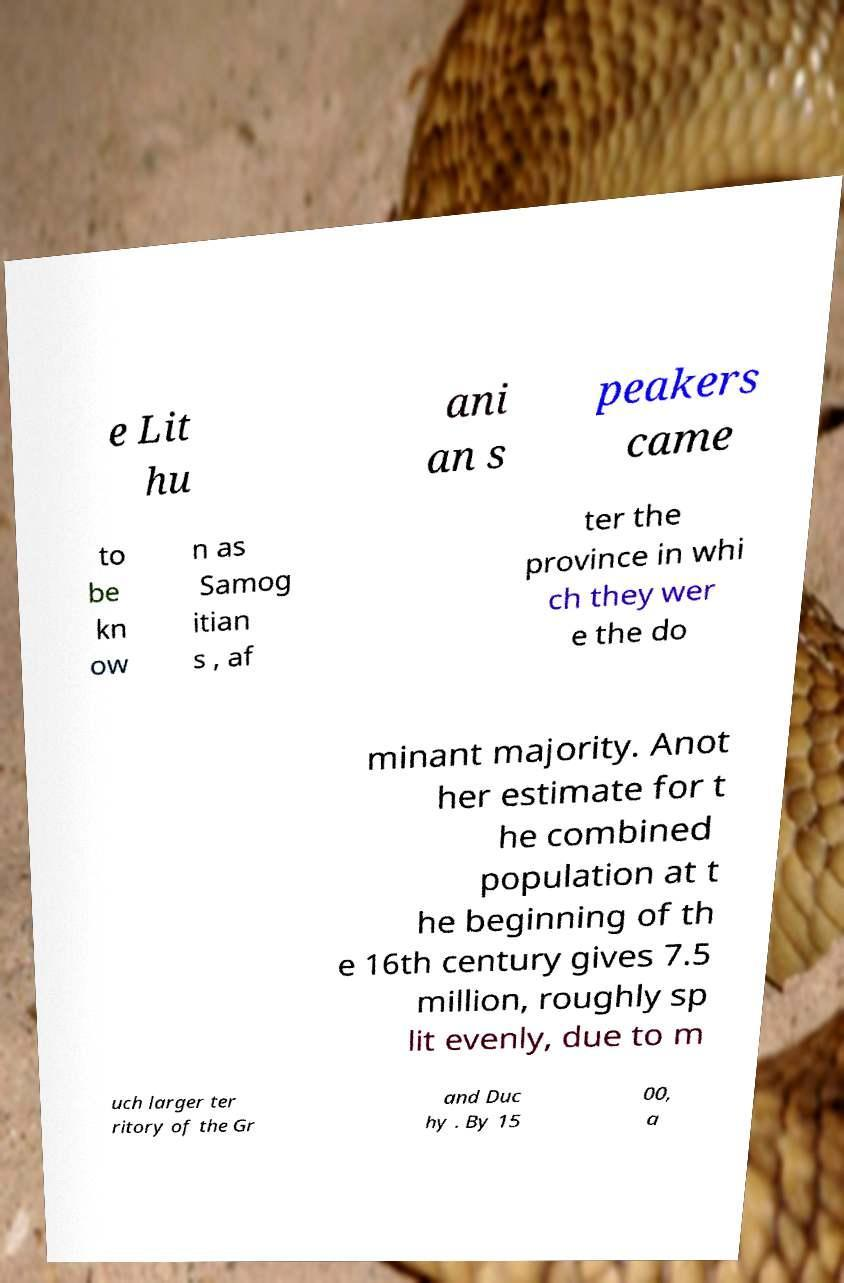Could you extract and type out the text from this image? e Lit hu ani an s peakers came to be kn ow n as Samog itian s , af ter the province in whi ch they wer e the do minant majority. Anot her estimate for t he combined population at t he beginning of th e 16th century gives 7.5 million, roughly sp lit evenly, due to m uch larger ter ritory of the Gr and Duc hy . By 15 00, a 